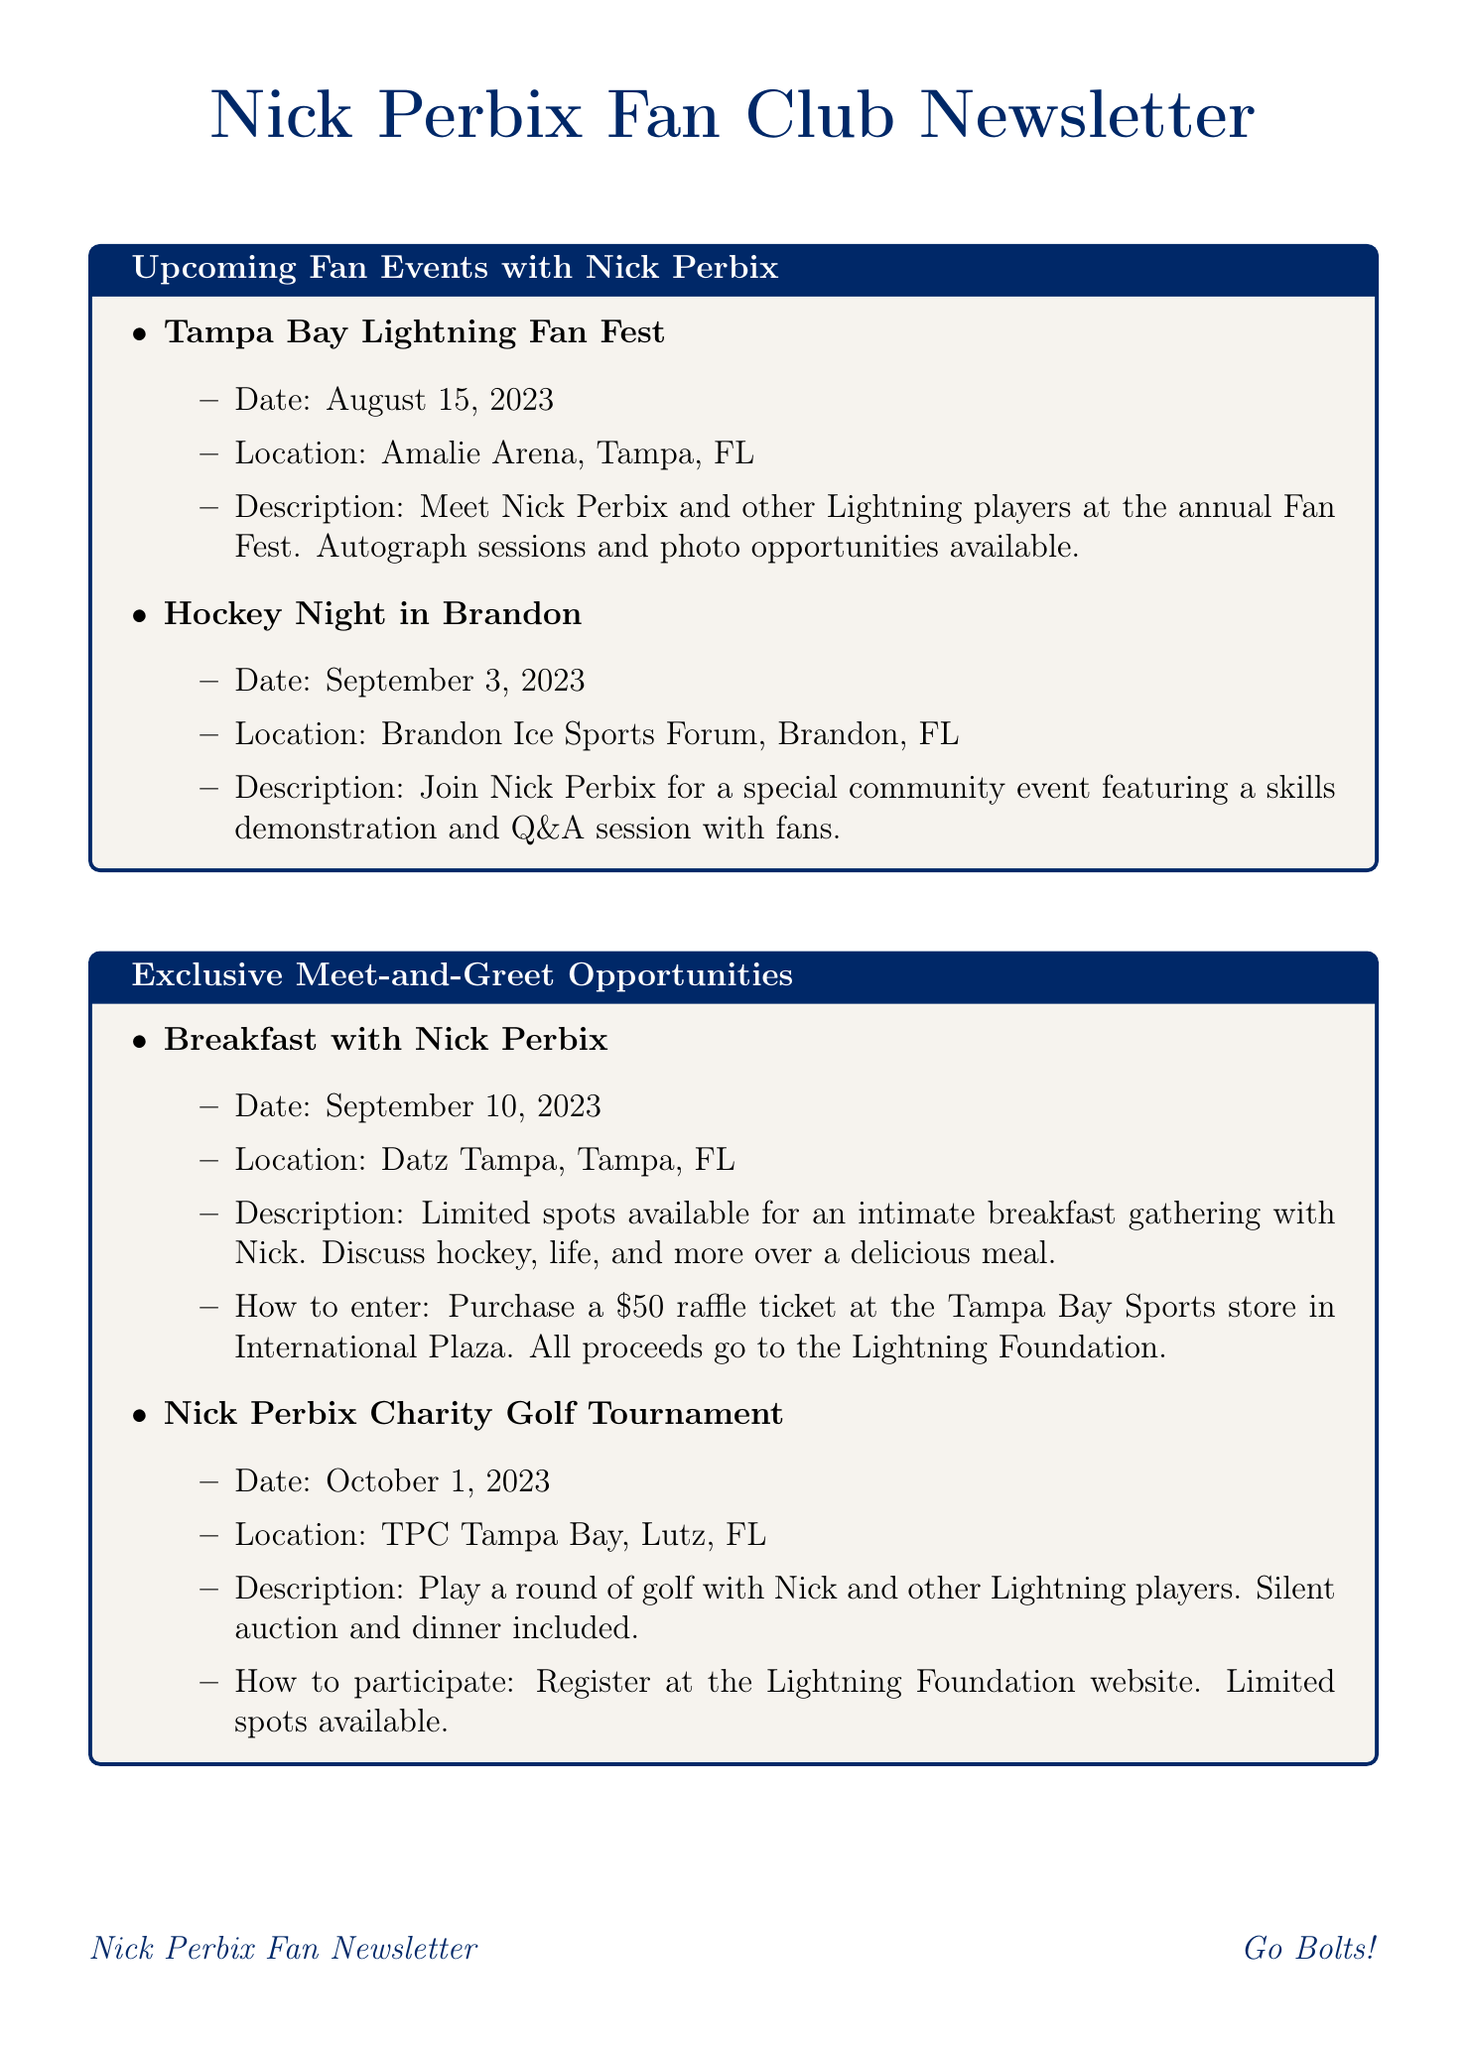What is the date of the Tampa Bay Lightning Fan Fest? The date for the Tampa Bay Lightning Fan Fest is clearly stated in the document under the Fan Events section.
Answer: August 15, 2023 Where will the Breakfast with Nick Perbix take place? The location for the Breakfast with Nick Perbix event is provided in the Exclusive Meet-and-Greet Opportunities section.
Answer: Datz Tampa, Tampa, FL What is the prize for the Nick Perbix's Biggest Fan Contest? The prize details for the contest are specified in the Ticket Giveaways section.
Answer: Two lower bowl tickets to the Lightning vs. Bruins game and a post-game meet-and-greet with Nick How can fans enter the Breakfast with Nick Perbix event? The method of entry for the breakfast event is listed in the Exclusive Meet-and-Greet Opportunities section.
Answer: Purchase a $50 raffle ticket What is the deadline to enter the Nick Perbix's Biggest Fan Contest? The deadline for the contest is mentioned in the Ticket Giveaways section.
Answer: October 15, 2023 Which event features a skills demonstration and Q&A session? The event that includes these activities is specifically described in the Upcoming Fan Events section of the document.
Answer: Hockey Night in Brandon When is the Nick Perbix Charity Golf Tournament? The date for the golf tournament is provided in the Exclusive Meet-and-Greet Opportunities section.
Answer: October 1, 2023 Where is the Nick Perbix Trivia Night being held? The location of the trivia night is mentioned in the Ticket Giveaways section.
Answer: Yeoman's Cask & Lion, Tampa, FL 